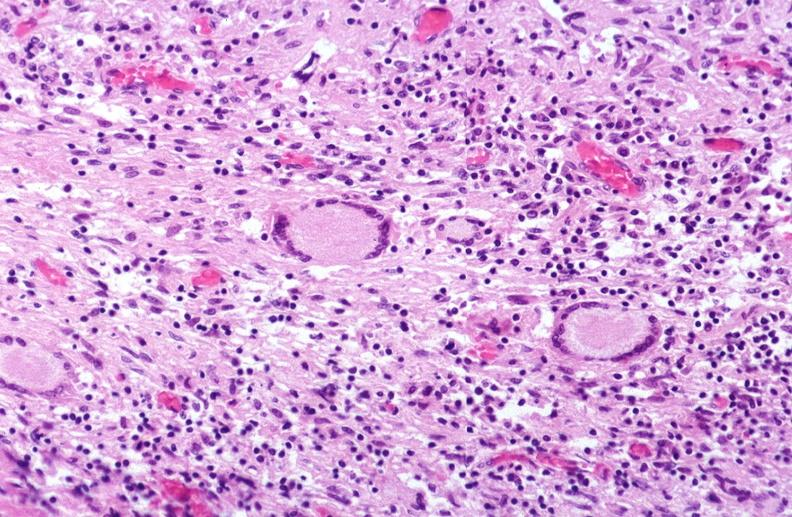what does this image show?
Answer the question using a single word or phrase. Lung 